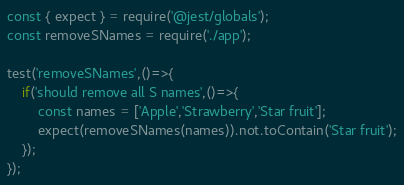Convert code to text. <code><loc_0><loc_0><loc_500><loc_500><_JavaScript_>const { expect } = require('@jest/globals');
const removeSNames = require('./app');

test('removeSNames',()=>{
    if('should remove all S names',()=>{
        const names = ['Apple','Strawberry','Star fruit'];
        expect(removeSNames(names)).not.toContain('Star fruit');
    });
});</code> 